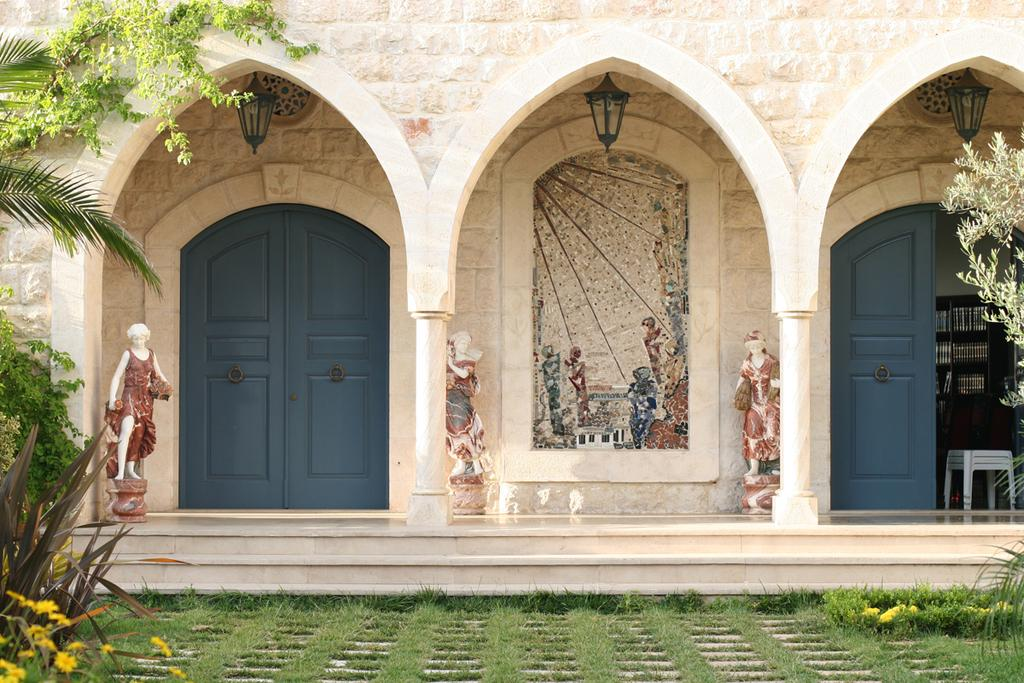What type of structure is visible in the image? There is a building in the image. What feature can be seen on the building? The building has doors. What is unique about the doors? The doors have lights. What objects are located behind the doors? There are stools behind the doors. What decorative elements are in front of the doors? There are sculptures in front of the doors. What type of vegetation is present in front of the doors? Trees, plants, and grass are present in front of the doors. What type of liquid is flowing from the hydrant in the image? There is no hydrant present in the image. What can be seen behind the building in the image? The provided facts do not mention anything about the back of the building, so we cannot answer this question definitively. 